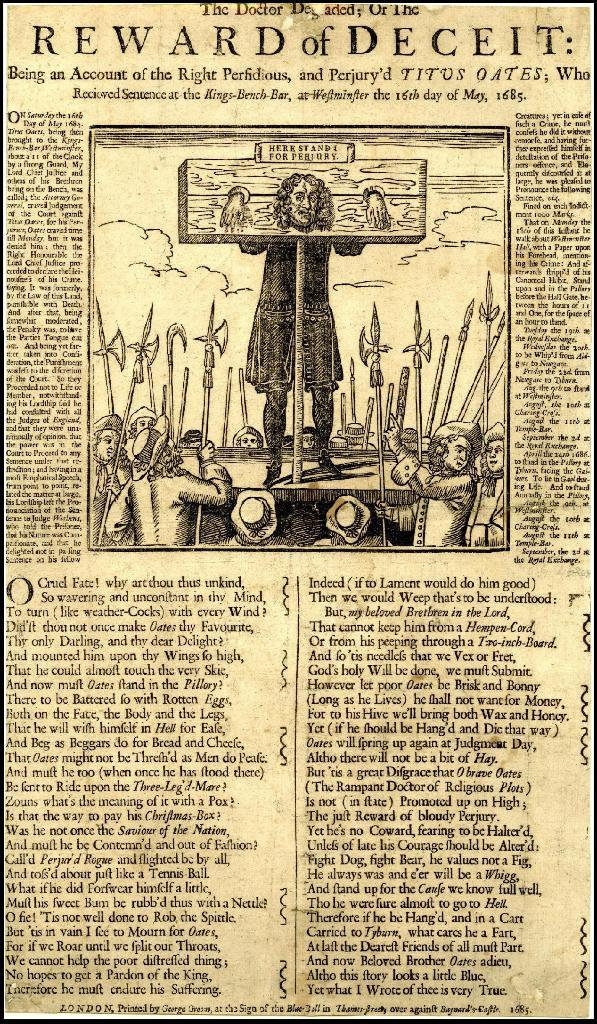What is the main object in the image? There is a newspaper in the image. What type of content can be found in the newspaper? The newspaper contains text and a picture. How much salt is sprinkled on the newspaper in the image? There is no salt present in the image; it features a newspaper with text and a picture. 